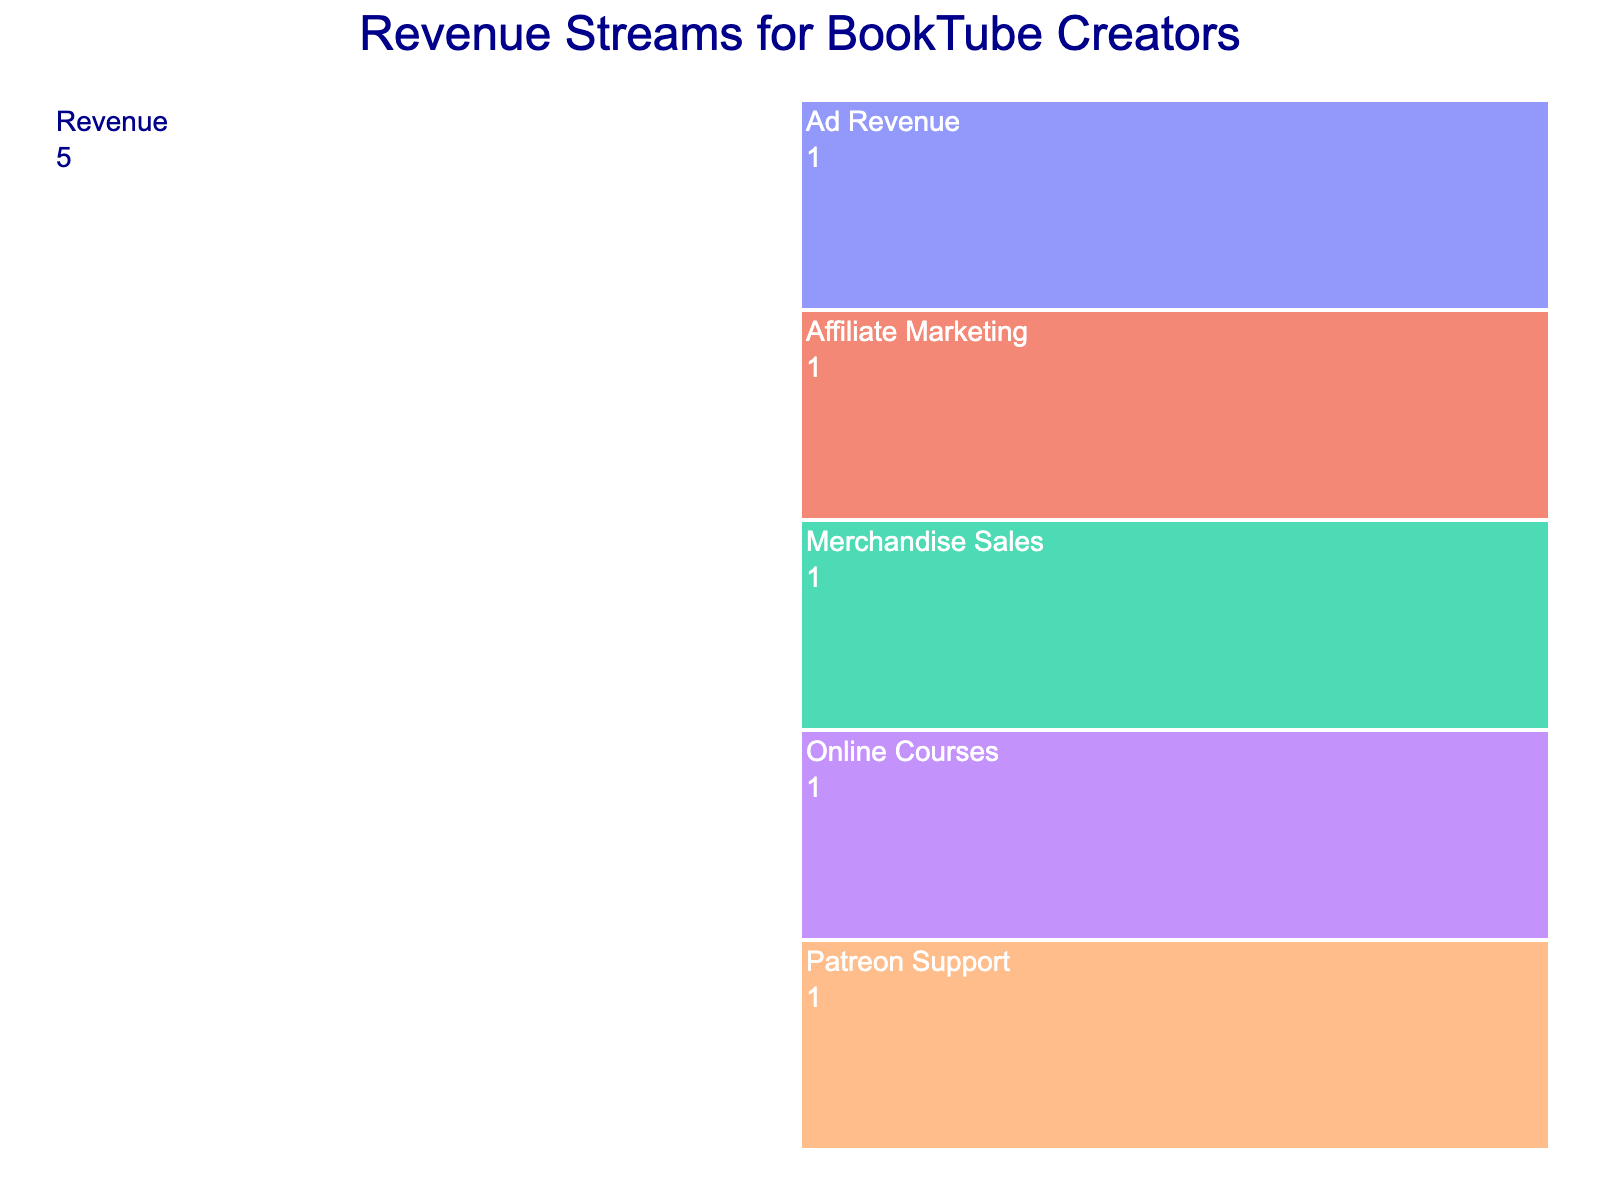what is the title of the figure? The title is usually placed at the top of the figure. In this case, you'll see the text "Revenue Streams for BookTube Creators" at the top center.
Answer: Revenue Streams for BookTube Creators What are all the revenue streams listed in the figure? The revenue streams are displayed as labels branching off from the main "Revenue" node. The figure shows the following sources: Ad Revenue, Affiliate Marketing, Merchandise Sales, Patreon Support, and Online Courses.
Answer: Ad Revenue, Affiliate Marketing, Merchandise Sales, Patreon Support, Online Courses How many different revenue sources are depicted in the figure? To find the number of different revenue sources, count the number of unique labels branching from the "Revenue" node.
Answer: 5 Which color scale is used in the figure? The color scale used in the figure is indicated in the description. From the provided information, the continuous color scale used is 'Viridis'. This describes the color gradient applied in the chart.
Answer: Viridis How is the relative importance of each revenue stream represented in the figure? The figure uses an icicle chart where each segment's size, usually proportional to a value like revenue amount, represents its relative importance. In this figure, each revenue stream segment is of equal size because they all have been assigned the same value (1).
Answer: Each segment is of equal size What do the labels inside and outside the segments indicate? The labels inside and outside the segments provide the names of the revenue sources and the assigned value for each. The internal labels are in white for easy visibility against the segment colors, and the external labels are in dark blue.
Answer: Revenue source names and their values Which text attributes are defined for readability, and how do they contribute? Contrast between text and background colors enhances readability: white text inside segments for ease against the darker segment colors and dark blue text outside segments for visibility against any lighter background. Font size is also adjusted to ensure clarity.
Answer: Text color and size for readability Can we draw any conclusions about which revenue stream is most significant from just this figure? No, we cannot conclude the most significant revenue stream because each segment is given an equal value, so their visual representation is the same. A different figure with actual revenue data would be needed.
Answer: No How does the icicle chart structure help in understanding the overall revenue pattern? The icicle chart helps visualize hierarchical data by branching from a common root (Revenue) to show how sub-categories (sources) contribute to the aggregate figure. It clearly represents the breakdown and grouping visually.
Answer: Hierarchy visualization How would the figure change if one source contributed significantly more revenue than the others? If one source contributed significantly more, its segment in the icicle chart would be larger compared to others, reflecting a higher value. This visual difference would help in easily identifying the dominant revenue stream.
Answer: The segment size will increase 